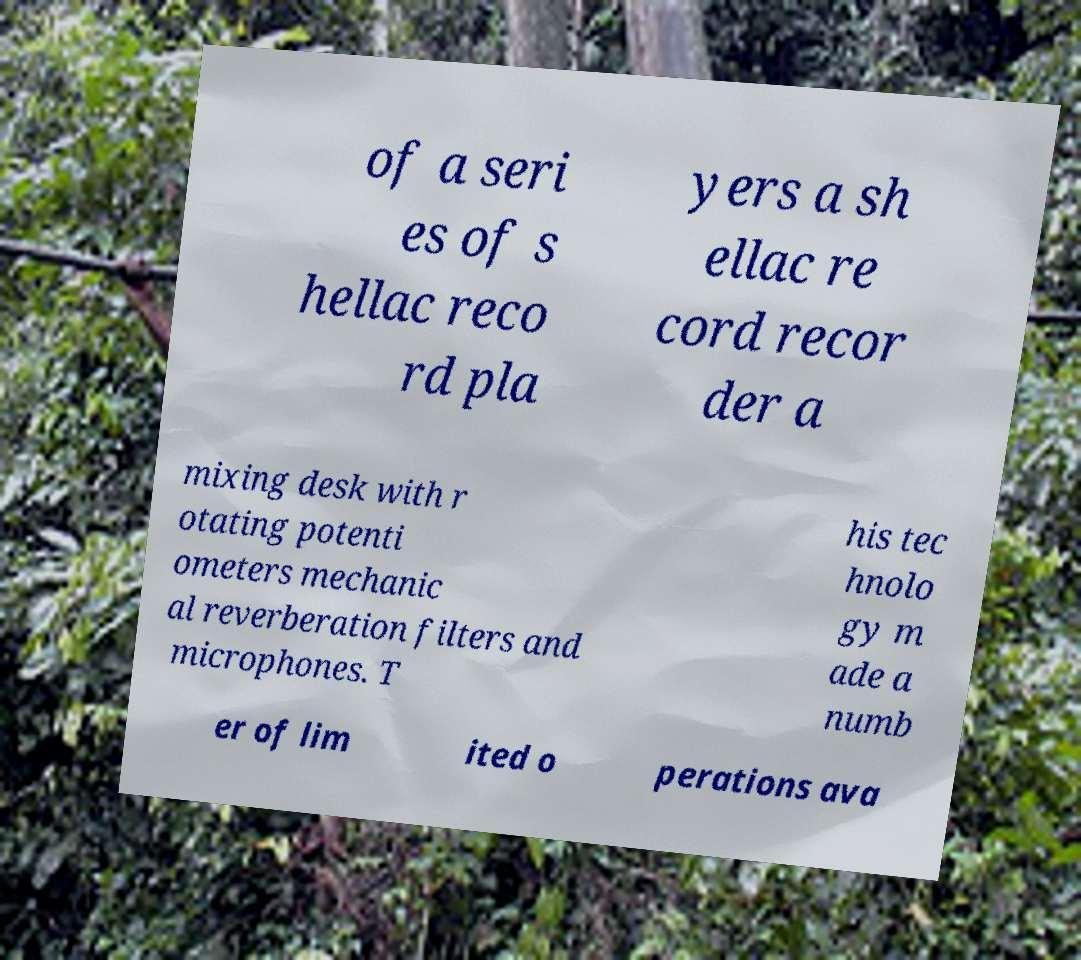Can you accurately transcribe the text from the provided image for me? of a seri es of s hellac reco rd pla yers a sh ellac re cord recor der a mixing desk with r otating potenti ometers mechanic al reverberation filters and microphones. T his tec hnolo gy m ade a numb er of lim ited o perations ava 